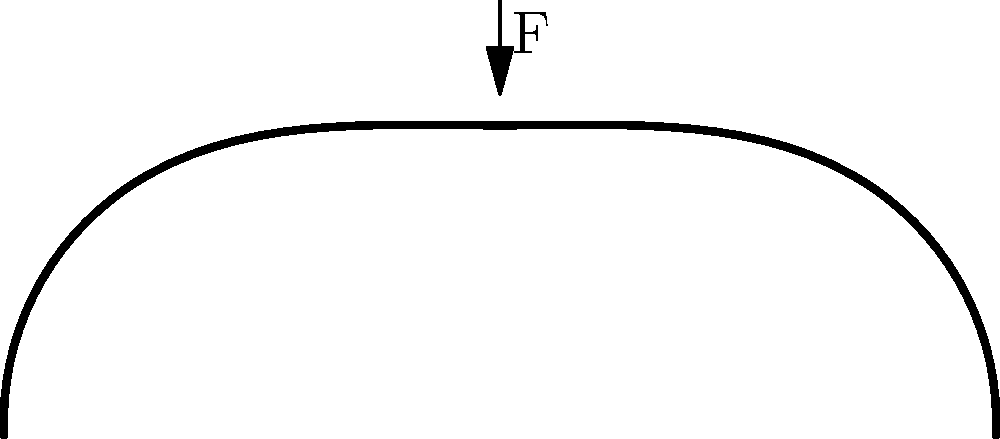During a Patriots game, a player takes a hard hit to the helmet. Assuming the impact force F is applied vertically at point B, which of the following statements about the stress distribution in the helmet shell is most accurate?

a) The stress is uniformly distributed across the entire helmet.
b) The stress is concentrated only at point B.
c) The stress is highest at point B and decreases towards points A and C.
d) The stress is lowest at point B and increases towards points A and C. Let's break this down step-by-step:

1) The helmet shell can be approximated as a curved beam under a point load.

2) When a force is applied to a curved structure, the stress distribution is not uniform due to the geometry.

3) In this case, the impact force F is applied at point B, which is the apex of the helmet's curvature.

4) According to the theory of curved beams under point loads:
   - The maximum stress occurs at the point of application of the force.
   - The stress decreases as we move away from the point of application.

5) This is because:
   - At point B, the force is concentrated on a small area, resulting in high stress.
   - As we move towards A and C, the force is distributed over a larger area, reducing the stress.

6) The stress distribution can be visualized as a series of contour lines, with the highest density at point B and decreasing density towards A and C.

7) This distribution is similar to how the impact of a stone thrown into a pond creates ripples that are most intense at the point of impact and decrease in intensity as they spread outward.

8) In football helmet design, this principle is crucial. Designers often use materials or structures that can distribute the impact force more evenly to reduce the risk of injury.

Therefore, the most accurate statement is that the stress is highest at point B and decreases towards points A and C.
Answer: c) The stress is highest at point B and decreases towards points A and C. 